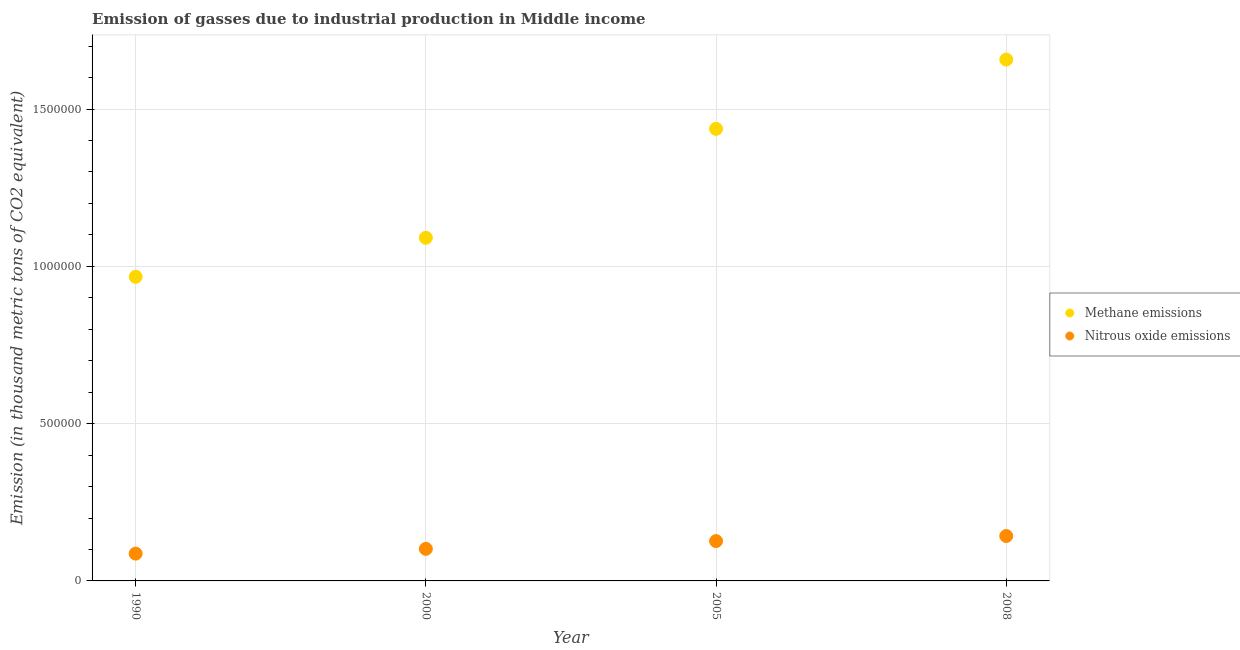What is the amount of nitrous oxide emissions in 2000?
Your answer should be very brief. 1.02e+05. Across all years, what is the maximum amount of methane emissions?
Keep it short and to the point. 1.66e+06. Across all years, what is the minimum amount of nitrous oxide emissions?
Make the answer very short. 8.68e+04. In which year was the amount of nitrous oxide emissions minimum?
Your response must be concise. 1990. What is the total amount of methane emissions in the graph?
Keep it short and to the point. 5.15e+06. What is the difference between the amount of methane emissions in 2005 and that in 2008?
Ensure brevity in your answer.  -2.20e+05. What is the difference between the amount of methane emissions in 1990 and the amount of nitrous oxide emissions in 2000?
Offer a terse response. 8.65e+05. What is the average amount of nitrous oxide emissions per year?
Give a very brief answer. 1.15e+05. In the year 2000, what is the difference between the amount of methane emissions and amount of nitrous oxide emissions?
Offer a very short reply. 9.89e+05. In how many years, is the amount of nitrous oxide emissions greater than 500000 thousand metric tons?
Keep it short and to the point. 0. What is the ratio of the amount of nitrous oxide emissions in 1990 to that in 2005?
Ensure brevity in your answer.  0.69. Is the amount of nitrous oxide emissions in 2000 less than that in 2008?
Ensure brevity in your answer.  Yes. Is the difference between the amount of nitrous oxide emissions in 1990 and 2008 greater than the difference between the amount of methane emissions in 1990 and 2008?
Your answer should be compact. Yes. What is the difference between the highest and the second highest amount of methane emissions?
Make the answer very short. 2.20e+05. What is the difference between the highest and the lowest amount of nitrous oxide emissions?
Offer a very short reply. 5.59e+04. Is the sum of the amount of nitrous oxide emissions in 2005 and 2008 greater than the maximum amount of methane emissions across all years?
Provide a short and direct response. No. Is the amount of methane emissions strictly greater than the amount of nitrous oxide emissions over the years?
Provide a short and direct response. Yes. How many years are there in the graph?
Your answer should be very brief. 4. Are the values on the major ticks of Y-axis written in scientific E-notation?
Make the answer very short. No. Does the graph contain any zero values?
Provide a short and direct response. No. Does the graph contain grids?
Your answer should be compact. Yes. Where does the legend appear in the graph?
Offer a very short reply. Center right. How many legend labels are there?
Make the answer very short. 2. What is the title of the graph?
Provide a short and direct response. Emission of gasses due to industrial production in Middle income. What is the label or title of the Y-axis?
Provide a short and direct response. Emission (in thousand metric tons of CO2 equivalent). What is the Emission (in thousand metric tons of CO2 equivalent) of Methane emissions in 1990?
Ensure brevity in your answer.  9.67e+05. What is the Emission (in thousand metric tons of CO2 equivalent) in Nitrous oxide emissions in 1990?
Provide a succinct answer. 8.68e+04. What is the Emission (in thousand metric tons of CO2 equivalent) in Methane emissions in 2000?
Offer a very short reply. 1.09e+06. What is the Emission (in thousand metric tons of CO2 equivalent) of Nitrous oxide emissions in 2000?
Make the answer very short. 1.02e+05. What is the Emission (in thousand metric tons of CO2 equivalent) of Methane emissions in 2005?
Provide a short and direct response. 1.44e+06. What is the Emission (in thousand metric tons of CO2 equivalent) of Nitrous oxide emissions in 2005?
Ensure brevity in your answer.  1.27e+05. What is the Emission (in thousand metric tons of CO2 equivalent) in Methane emissions in 2008?
Ensure brevity in your answer.  1.66e+06. What is the Emission (in thousand metric tons of CO2 equivalent) of Nitrous oxide emissions in 2008?
Your response must be concise. 1.43e+05. Across all years, what is the maximum Emission (in thousand metric tons of CO2 equivalent) of Methane emissions?
Give a very brief answer. 1.66e+06. Across all years, what is the maximum Emission (in thousand metric tons of CO2 equivalent) in Nitrous oxide emissions?
Make the answer very short. 1.43e+05. Across all years, what is the minimum Emission (in thousand metric tons of CO2 equivalent) in Methane emissions?
Provide a succinct answer. 9.67e+05. Across all years, what is the minimum Emission (in thousand metric tons of CO2 equivalent) in Nitrous oxide emissions?
Provide a short and direct response. 8.68e+04. What is the total Emission (in thousand metric tons of CO2 equivalent) of Methane emissions in the graph?
Ensure brevity in your answer.  5.15e+06. What is the total Emission (in thousand metric tons of CO2 equivalent) of Nitrous oxide emissions in the graph?
Make the answer very short. 4.58e+05. What is the difference between the Emission (in thousand metric tons of CO2 equivalent) in Methane emissions in 1990 and that in 2000?
Give a very brief answer. -1.24e+05. What is the difference between the Emission (in thousand metric tons of CO2 equivalent) of Nitrous oxide emissions in 1990 and that in 2000?
Offer a very short reply. -1.52e+04. What is the difference between the Emission (in thousand metric tons of CO2 equivalent) of Methane emissions in 1990 and that in 2005?
Make the answer very short. -4.70e+05. What is the difference between the Emission (in thousand metric tons of CO2 equivalent) of Nitrous oxide emissions in 1990 and that in 2005?
Make the answer very short. -3.98e+04. What is the difference between the Emission (in thousand metric tons of CO2 equivalent) of Methane emissions in 1990 and that in 2008?
Give a very brief answer. -6.90e+05. What is the difference between the Emission (in thousand metric tons of CO2 equivalent) in Nitrous oxide emissions in 1990 and that in 2008?
Ensure brevity in your answer.  -5.59e+04. What is the difference between the Emission (in thousand metric tons of CO2 equivalent) of Methane emissions in 2000 and that in 2005?
Make the answer very short. -3.46e+05. What is the difference between the Emission (in thousand metric tons of CO2 equivalent) in Nitrous oxide emissions in 2000 and that in 2005?
Ensure brevity in your answer.  -2.47e+04. What is the difference between the Emission (in thousand metric tons of CO2 equivalent) of Methane emissions in 2000 and that in 2008?
Keep it short and to the point. -5.66e+05. What is the difference between the Emission (in thousand metric tons of CO2 equivalent) in Nitrous oxide emissions in 2000 and that in 2008?
Ensure brevity in your answer.  -4.08e+04. What is the difference between the Emission (in thousand metric tons of CO2 equivalent) of Methane emissions in 2005 and that in 2008?
Provide a succinct answer. -2.20e+05. What is the difference between the Emission (in thousand metric tons of CO2 equivalent) in Nitrous oxide emissions in 2005 and that in 2008?
Give a very brief answer. -1.61e+04. What is the difference between the Emission (in thousand metric tons of CO2 equivalent) in Methane emissions in 1990 and the Emission (in thousand metric tons of CO2 equivalent) in Nitrous oxide emissions in 2000?
Ensure brevity in your answer.  8.65e+05. What is the difference between the Emission (in thousand metric tons of CO2 equivalent) of Methane emissions in 1990 and the Emission (in thousand metric tons of CO2 equivalent) of Nitrous oxide emissions in 2005?
Your answer should be compact. 8.40e+05. What is the difference between the Emission (in thousand metric tons of CO2 equivalent) of Methane emissions in 1990 and the Emission (in thousand metric tons of CO2 equivalent) of Nitrous oxide emissions in 2008?
Ensure brevity in your answer.  8.24e+05. What is the difference between the Emission (in thousand metric tons of CO2 equivalent) in Methane emissions in 2000 and the Emission (in thousand metric tons of CO2 equivalent) in Nitrous oxide emissions in 2005?
Provide a succinct answer. 9.64e+05. What is the difference between the Emission (in thousand metric tons of CO2 equivalent) of Methane emissions in 2000 and the Emission (in thousand metric tons of CO2 equivalent) of Nitrous oxide emissions in 2008?
Give a very brief answer. 9.48e+05. What is the difference between the Emission (in thousand metric tons of CO2 equivalent) of Methane emissions in 2005 and the Emission (in thousand metric tons of CO2 equivalent) of Nitrous oxide emissions in 2008?
Provide a succinct answer. 1.29e+06. What is the average Emission (in thousand metric tons of CO2 equivalent) of Methane emissions per year?
Give a very brief answer. 1.29e+06. What is the average Emission (in thousand metric tons of CO2 equivalent) of Nitrous oxide emissions per year?
Offer a terse response. 1.15e+05. In the year 1990, what is the difference between the Emission (in thousand metric tons of CO2 equivalent) of Methane emissions and Emission (in thousand metric tons of CO2 equivalent) of Nitrous oxide emissions?
Provide a succinct answer. 8.80e+05. In the year 2000, what is the difference between the Emission (in thousand metric tons of CO2 equivalent) in Methane emissions and Emission (in thousand metric tons of CO2 equivalent) in Nitrous oxide emissions?
Offer a terse response. 9.89e+05. In the year 2005, what is the difference between the Emission (in thousand metric tons of CO2 equivalent) of Methane emissions and Emission (in thousand metric tons of CO2 equivalent) of Nitrous oxide emissions?
Give a very brief answer. 1.31e+06. In the year 2008, what is the difference between the Emission (in thousand metric tons of CO2 equivalent) in Methane emissions and Emission (in thousand metric tons of CO2 equivalent) in Nitrous oxide emissions?
Make the answer very short. 1.51e+06. What is the ratio of the Emission (in thousand metric tons of CO2 equivalent) of Methane emissions in 1990 to that in 2000?
Ensure brevity in your answer.  0.89. What is the ratio of the Emission (in thousand metric tons of CO2 equivalent) of Nitrous oxide emissions in 1990 to that in 2000?
Offer a terse response. 0.85. What is the ratio of the Emission (in thousand metric tons of CO2 equivalent) in Methane emissions in 1990 to that in 2005?
Offer a very short reply. 0.67. What is the ratio of the Emission (in thousand metric tons of CO2 equivalent) of Nitrous oxide emissions in 1990 to that in 2005?
Ensure brevity in your answer.  0.69. What is the ratio of the Emission (in thousand metric tons of CO2 equivalent) in Methane emissions in 1990 to that in 2008?
Your response must be concise. 0.58. What is the ratio of the Emission (in thousand metric tons of CO2 equivalent) of Nitrous oxide emissions in 1990 to that in 2008?
Your answer should be compact. 0.61. What is the ratio of the Emission (in thousand metric tons of CO2 equivalent) of Methane emissions in 2000 to that in 2005?
Your answer should be very brief. 0.76. What is the ratio of the Emission (in thousand metric tons of CO2 equivalent) of Nitrous oxide emissions in 2000 to that in 2005?
Ensure brevity in your answer.  0.81. What is the ratio of the Emission (in thousand metric tons of CO2 equivalent) in Methane emissions in 2000 to that in 2008?
Keep it short and to the point. 0.66. What is the ratio of the Emission (in thousand metric tons of CO2 equivalent) in Nitrous oxide emissions in 2000 to that in 2008?
Provide a short and direct response. 0.71. What is the ratio of the Emission (in thousand metric tons of CO2 equivalent) of Methane emissions in 2005 to that in 2008?
Provide a short and direct response. 0.87. What is the ratio of the Emission (in thousand metric tons of CO2 equivalent) of Nitrous oxide emissions in 2005 to that in 2008?
Offer a very short reply. 0.89. What is the difference between the highest and the second highest Emission (in thousand metric tons of CO2 equivalent) in Methane emissions?
Provide a short and direct response. 2.20e+05. What is the difference between the highest and the second highest Emission (in thousand metric tons of CO2 equivalent) in Nitrous oxide emissions?
Your answer should be very brief. 1.61e+04. What is the difference between the highest and the lowest Emission (in thousand metric tons of CO2 equivalent) in Methane emissions?
Keep it short and to the point. 6.90e+05. What is the difference between the highest and the lowest Emission (in thousand metric tons of CO2 equivalent) in Nitrous oxide emissions?
Offer a very short reply. 5.59e+04. 